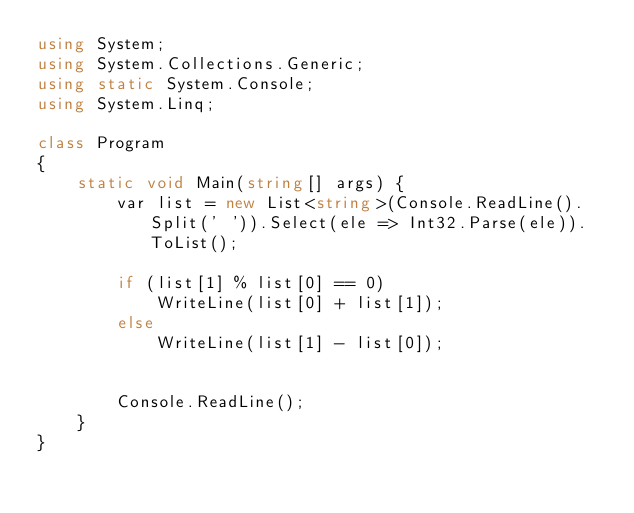<code> <loc_0><loc_0><loc_500><loc_500><_C#_>using System;
using System.Collections.Generic;
using static System.Console;
using System.Linq;

class Program
{
    static void Main(string[] args) {
        var list = new List<string>(Console.ReadLine().Split(' ')).Select(ele => Int32.Parse(ele)).ToList();

        if (list[1] % list[0] == 0)
            WriteLine(list[0] + list[1]);
        else
            WriteLine(list[1] - list[0]);


        Console.ReadLine();
    }
}
</code> 